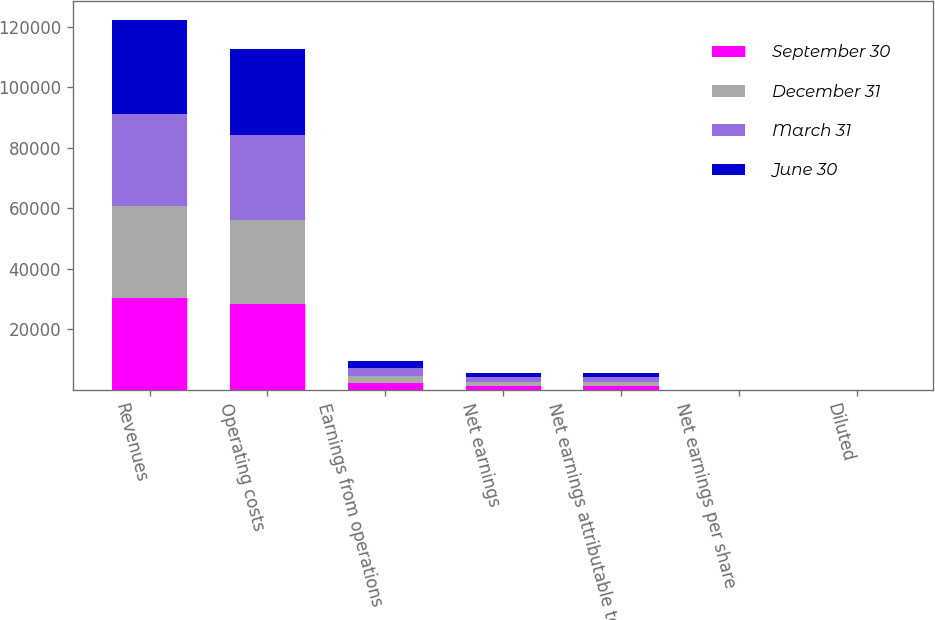<chart> <loc_0><loc_0><loc_500><loc_500><stacked_bar_chart><ecel><fcel>Revenues<fcel>Operating costs<fcel>Earnings from operations<fcel>Net earnings<fcel>Net earnings attributable to<fcel>Net earnings per share<fcel>Diluted<nl><fcel>September 30<fcel>30340<fcel>28201<fcel>2139<fcel>1240<fcel>1192<fcel>1.17<fcel>1.16<nl><fcel>December 31<fcel>30408<fcel>28007<fcel>2401<fcel>1436<fcel>1436<fcel>1.42<fcel>1.4<nl><fcel>March 31<fcel>30624<fcel>27993<fcel>2631<fcel>1570<fcel>1570<fcel>1.56<fcel>1.53<nl><fcel>June 30<fcel>31117<fcel>28665<fcel>2452<fcel>1427<fcel>1427<fcel>1.43<fcel>1.41<nl></chart> 